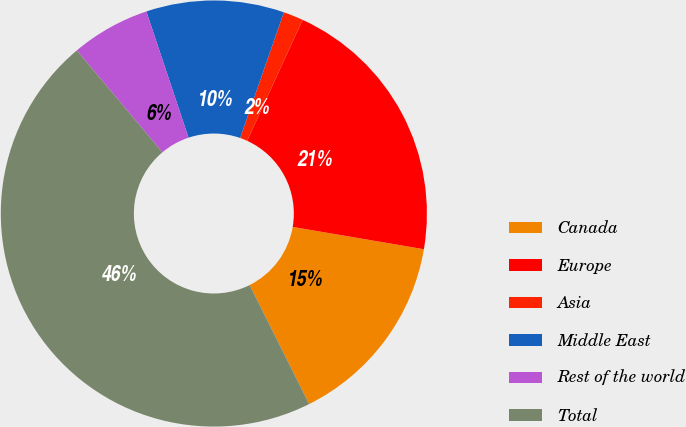Convert chart to OTSL. <chart><loc_0><loc_0><loc_500><loc_500><pie_chart><fcel>Canada<fcel>Europe<fcel>Asia<fcel>Middle East<fcel>Rest of the world<fcel>Total<nl><fcel>14.94%<fcel>20.84%<fcel>1.51%<fcel>10.46%<fcel>5.99%<fcel>46.26%<nl></chart> 